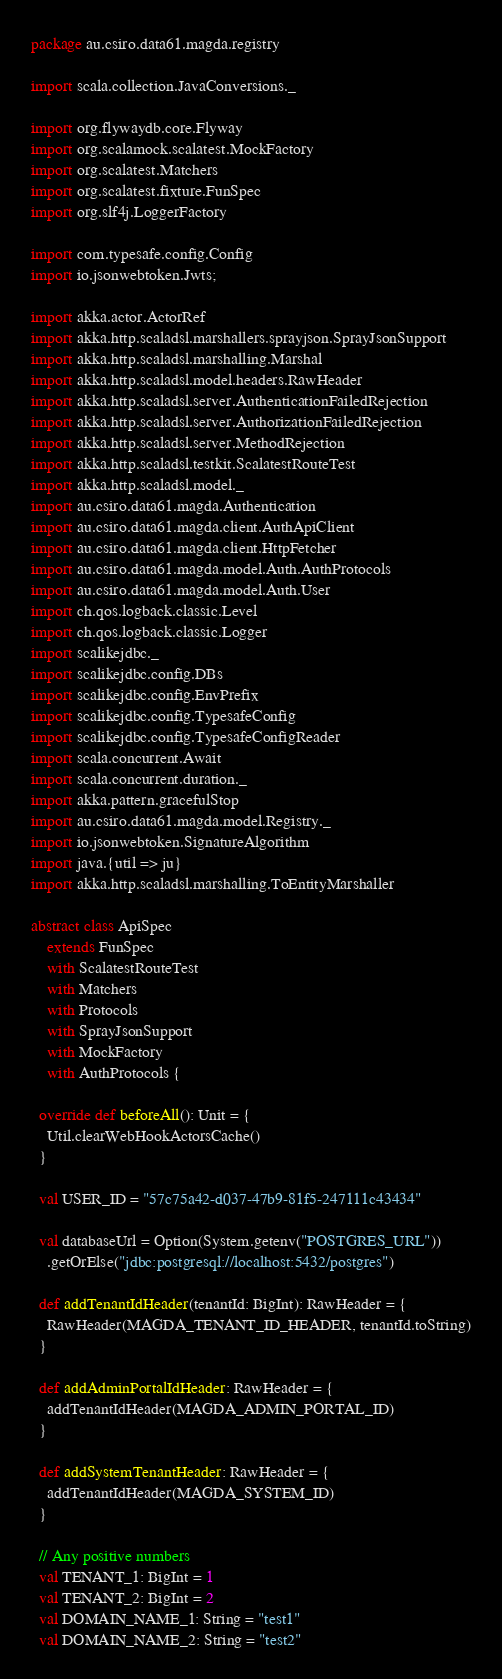<code> <loc_0><loc_0><loc_500><loc_500><_Scala_>package au.csiro.data61.magda.registry

import scala.collection.JavaConversions._

import org.flywaydb.core.Flyway
import org.scalamock.scalatest.MockFactory
import org.scalatest.Matchers
import org.scalatest.fixture.FunSpec
import org.slf4j.LoggerFactory

import com.typesafe.config.Config
import io.jsonwebtoken.Jwts;

import akka.actor.ActorRef
import akka.http.scaladsl.marshallers.sprayjson.SprayJsonSupport
import akka.http.scaladsl.marshalling.Marshal
import akka.http.scaladsl.model.headers.RawHeader
import akka.http.scaladsl.server.AuthenticationFailedRejection
import akka.http.scaladsl.server.AuthorizationFailedRejection
import akka.http.scaladsl.server.MethodRejection
import akka.http.scaladsl.testkit.ScalatestRouteTest
import akka.http.scaladsl.model._
import au.csiro.data61.magda.Authentication
import au.csiro.data61.magda.client.AuthApiClient
import au.csiro.data61.magda.client.HttpFetcher
import au.csiro.data61.magda.model.Auth.AuthProtocols
import au.csiro.data61.magda.model.Auth.User
import ch.qos.logback.classic.Level
import ch.qos.logback.classic.Logger
import scalikejdbc._
import scalikejdbc.config.DBs
import scalikejdbc.config.EnvPrefix
import scalikejdbc.config.TypesafeConfig
import scalikejdbc.config.TypesafeConfigReader
import scala.concurrent.Await
import scala.concurrent.duration._
import akka.pattern.gracefulStop
import au.csiro.data61.magda.model.Registry._
import io.jsonwebtoken.SignatureAlgorithm
import java.{util => ju}
import akka.http.scaladsl.marshalling.ToEntityMarshaller

abstract class ApiSpec
    extends FunSpec
    with ScalatestRouteTest
    with Matchers
    with Protocols
    with SprayJsonSupport
    with MockFactory
    with AuthProtocols {

  override def beforeAll(): Unit = {
    Util.clearWebHookActorsCache()
  }

  val USER_ID = "57c75a42-d037-47b9-81f5-247111c43434"

  val databaseUrl = Option(System.getenv("POSTGRES_URL"))
    .getOrElse("jdbc:postgresql://localhost:5432/postgres")

  def addTenantIdHeader(tenantId: BigInt): RawHeader = {
    RawHeader(MAGDA_TENANT_ID_HEADER, tenantId.toString)
  }

  def addAdminPortalIdHeader: RawHeader = {
    addTenantIdHeader(MAGDA_ADMIN_PORTAL_ID)
  }

  def addSystemTenantHeader: RawHeader = {
    addTenantIdHeader(MAGDA_SYSTEM_ID)
  }

  // Any positive numbers
  val TENANT_1: BigInt = 1
  val TENANT_2: BigInt = 2
  val DOMAIN_NAME_1: String = "test1"
  val DOMAIN_NAME_2: String = "test2"
</code> 